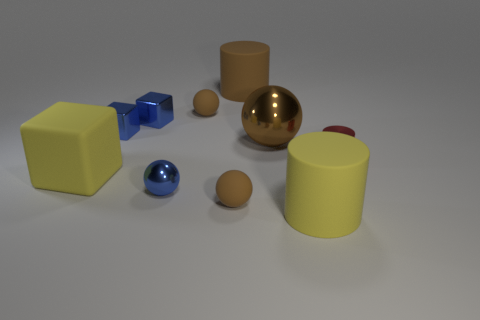Subtract all purple blocks. How many brown spheres are left? 3 Subtract all cyan balls. Subtract all green cubes. How many balls are left? 4 Subtract all spheres. How many objects are left? 6 Subtract 1 red cylinders. How many objects are left? 9 Subtract all blue metallic spheres. Subtract all big yellow objects. How many objects are left? 7 Add 1 tiny cylinders. How many tiny cylinders are left? 2 Add 2 small things. How many small things exist? 8 